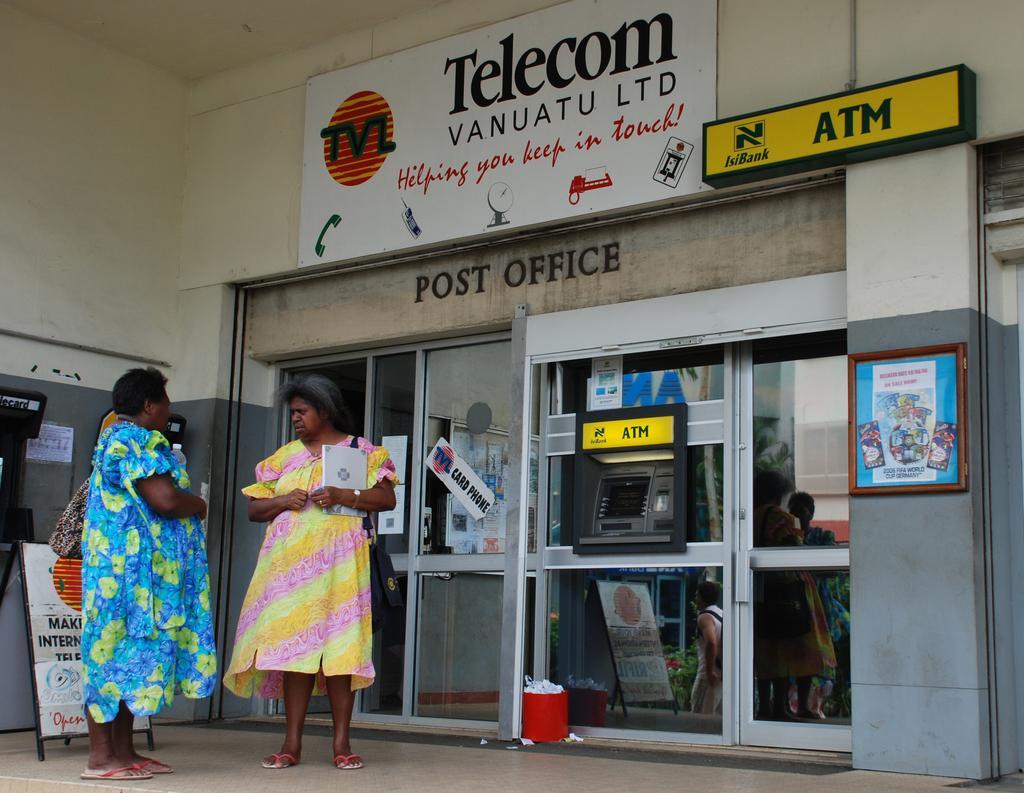Could you give a brief overview of what you see in this image? In the picture I can see two women wearing yellow and blue color dress standing on floor and holding some objects in their hands, on right side of the picture there are some glass doors, ATM, top of the picture there are some boards attached to the wall, on left side of the picture there are some boards on floor and there is a wall. 